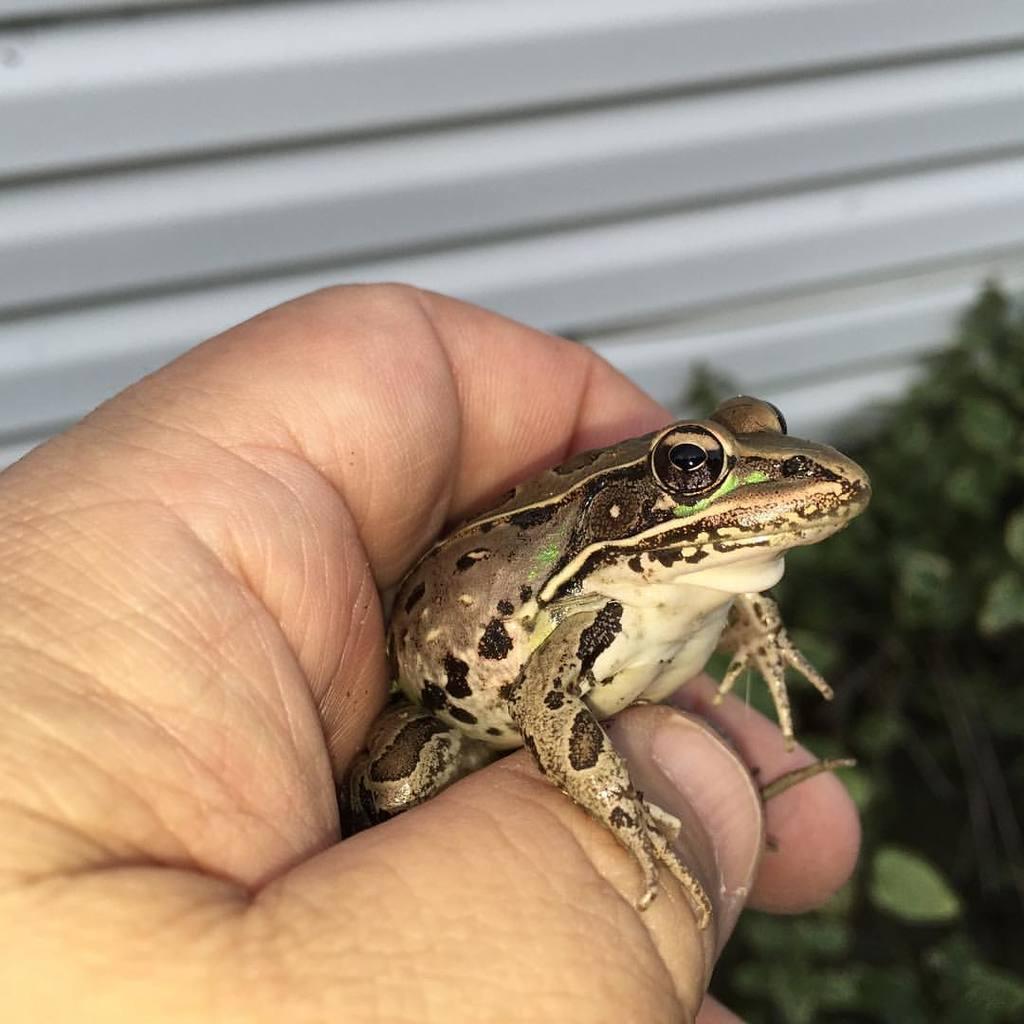Please provide a concise description of this image. In the image we can see a human hand and a frog. This is a plant. 